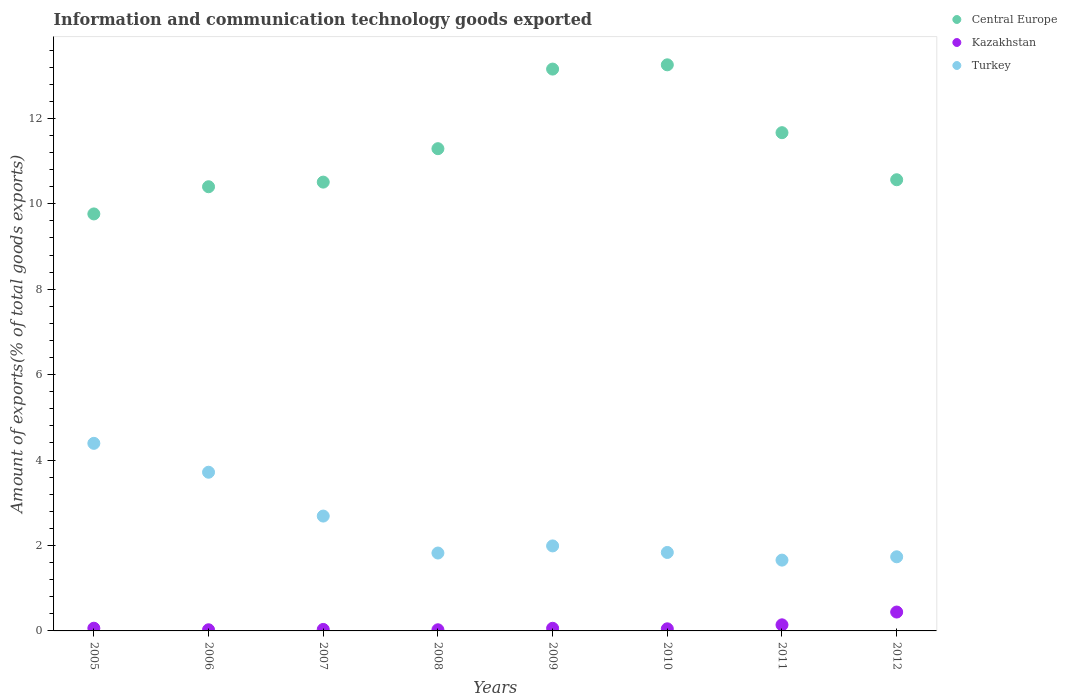What is the amount of goods exported in Kazakhstan in 2010?
Keep it short and to the point. 0.05. Across all years, what is the maximum amount of goods exported in Turkey?
Your response must be concise. 4.39. Across all years, what is the minimum amount of goods exported in Kazakhstan?
Provide a succinct answer. 0.03. In which year was the amount of goods exported in Central Europe maximum?
Provide a succinct answer. 2010. In which year was the amount of goods exported in Central Europe minimum?
Ensure brevity in your answer.  2005. What is the total amount of goods exported in Central Europe in the graph?
Your answer should be very brief. 90.6. What is the difference between the amount of goods exported in Central Europe in 2006 and that in 2012?
Your answer should be very brief. -0.16. What is the difference between the amount of goods exported in Central Europe in 2011 and the amount of goods exported in Turkey in 2012?
Your answer should be compact. 9.93. What is the average amount of goods exported in Turkey per year?
Keep it short and to the point. 2.48. In the year 2006, what is the difference between the amount of goods exported in Central Europe and amount of goods exported in Kazakhstan?
Your answer should be compact. 10.37. What is the ratio of the amount of goods exported in Kazakhstan in 2005 to that in 2011?
Ensure brevity in your answer.  0.44. What is the difference between the highest and the second highest amount of goods exported in Kazakhstan?
Give a very brief answer. 0.3. What is the difference between the highest and the lowest amount of goods exported in Central Europe?
Offer a terse response. 3.49. In how many years, is the amount of goods exported in Turkey greater than the average amount of goods exported in Turkey taken over all years?
Give a very brief answer. 3. Is it the case that in every year, the sum of the amount of goods exported in Turkey and amount of goods exported in Kazakhstan  is greater than the amount of goods exported in Central Europe?
Your answer should be very brief. No. Does the amount of goods exported in Kazakhstan monotonically increase over the years?
Give a very brief answer. No. Is the amount of goods exported in Turkey strictly less than the amount of goods exported in Kazakhstan over the years?
Give a very brief answer. No. How many dotlines are there?
Provide a succinct answer. 3. How many years are there in the graph?
Offer a very short reply. 8. Are the values on the major ticks of Y-axis written in scientific E-notation?
Your answer should be very brief. No. Where does the legend appear in the graph?
Provide a succinct answer. Top right. What is the title of the graph?
Your answer should be very brief. Information and communication technology goods exported. What is the label or title of the Y-axis?
Offer a terse response. Amount of exports(% of total goods exports). What is the Amount of exports(% of total goods exports) of Central Europe in 2005?
Provide a succinct answer. 9.76. What is the Amount of exports(% of total goods exports) in Kazakhstan in 2005?
Offer a terse response. 0.06. What is the Amount of exports(% of total goods exports) of Turkey in 2005?
Your answer should be compact. 4.39. What is the Amount of exports(% of total goods exports) in Central Europe in 2006?
Your answer should be compact. 10.4. What is the Amount of exports(% of total goods exports) in Kazakhstan in 2006?
Provide a succinct answer. 0.03. What is the Amount of exports(% of total goods exports) of Turkey in 2006?
Provide a succinct answer. 3.72. What is the Amount of exports(% of total goods exports) in Central Europe in 2007?
Your response must be concise. 10.51. What is the Amount of exports(% of total goods exports) of Kazakhstan in 2007?
Make the answer very short. 0.03. What is the Amount of exports(% of total goods exports) of Turkey in 2007?
Offer a very short reply. 2.69. What is the Amount of exports(% of total goods exports) of Central Europe in 2008?
Give a very brief answer. 11.29. What is the Amount of exports(% of total goods exports) in Kazakhstan in 2008?
Offer a very short reply. 0.03. What is the Amount of exports(% of total goods exports) in Turkey in 2008?
Your answer should be compact. 1.82. What is the Amount of exports(% of total goods exports) in Central Europe in 2009?
Your answer should be compact. 13.15. What is the Amount of exports(% of total goods exports) of Kazakhstan in 2009?
Offer a terse response. 0.06. What is the Amount of exports(% of total goods exports) of Turkey in 2009?
Offer a very short reply. 1.99. What is the Amount of exports(% of total goods exports) of Central Europe in 2010?
Offer a very short reply. 13.25. What is the Amount of exports(% of total goods exports) of Kazakhstan in 2010?
Give a very brief answer. 0.05. What is the Amount of exports(% of total goods exports) of Turkey in 2010?
Ensure brevity in your answer.  1.84. What is the Amount of exports(% of total goods exports) in Central Europe in 2011?
Your answer should be compact. 11.67. What is the Amount of exports(% of total goods exports) of Kazakhstan in 2011?
Ensure brevity in your answer.  0.14. What is the Amount of exports(% of total goods exports) in Turkey in 2011?
Provide a short and direct response. 1.66. What is the Amount of exports(% of total goods exports) of Central Europe in 2012?
Give a very brief answer. 10.56. What is the Amount of exports(% of total goods exports) in Kazakhstan in 2012?
Give a very brief answer. 0.44. What is the Amount of exports(% of total goods exports) in Turkey in 2012?
Give a very brief answer. 1.74. Across all years, what is the maximum Amount of exports(% of total goods exports) in Central Europe?
Keep it short and to the point. 13.25. Across all years, what is the maximum Amount of exports(% of total goods exports) of Kazakhstan?
Your answer should be very brief. 0.44. Across all years, what is the maximum Amount of exports(% of total goods exports) in Turkey?
Give a very brief answer. 4.39. Across all years, what is the minimum Amount of exports(% of total goods exports) of Central Europe?
Offer a terse response. 9.76. Across all years, what is the minimum Amount of exports(% of total goods exports) of Kazakhstan?
Provide a short and direct response. 0.03. Across all years, what is the minimum Amount of exports(% of total goods exports) in Turkey?
Keep it short and to the point. 1.66. What is the total Amount of exports(% of total goods exports) in Central Europe in the graph?
Keep it short and to the point. 90.6. What is the total Amount of exports(% of total goods exports) in Kazakhstan in the graph?
Offer a very short reply. 0.85. What is the total Amount of exports(% of total goods exports) in Turkey in the graph?
Offer a very short reply. 19.84. What is the difference between the Amount of exports(% of total goods exports) of Central Europe in 2005 and that in 2006?
Provide a short and direct response. -0.64. What is the difference between the Amount of exports(% of total goods exports) of Kazakhstan in 2005 and that in 2006?
Give a very brief answer. 0.04. What is the difference between the Amount of exports(% of total goods exports) of Turkey in 2005 and that in 2006?
Your response must be concise. 0.68. What is the difference between the Amount of exports(% of total goods exports) in Central Europe in 2005 and that in 2007?
Your answer should be compact. -0.74. What is the difference between the Amount of exports(% of total goods exports) of Kazakhstan in 2005 and that in 2007?
Give a very brief answer. 0.03. What is the difference between the Amount of exports(% of total goods exports) of Turkey in 2005 and that in 2007?
Offer a terse response. 1.7. What is the difference between the Amount of exports(% of total goods exports) of Central Europe in 2005 and that in 2008?
Your response must be concise. -1.53. What is the difference between the Amount of exports(% of total goods exports) in Kazakhstan in 2005 and that in 2008?
Make the answer very short. 0.04. What is the difference between the Amount of exports(% of total goods exports) in Turkey in 2005 and that in 2008?
Provide a succinct answer. 2.57. What is the difference between the Amount of exports(% of total goods exports) in Central Europe in 2005 and that in 2009?
Give a very brief answer. -3.39. What is the difference between the Amount of exports(% of total goods exports) of Kazakhstan in 2005 and that in 2009?
Provide a short and direct response. 0. What is the difference between the Amount of exports(% of total goods exports) in Turkey in 2005 and that in 2009?
Offer a very short reply. 2.4. What is the difference between the Amount of exports(% of total goods exports) in Central Europe in 2005 and that in 2010?
Your answer should be very brief. -3.49. What is the difference between the Amount of exports(% of total goods exports) in Kazakhstan in 2005 and that in 2010?
Keep it short and to the point. 0.01. What is the difference between the Amount of exports(% of total goods exports) of Turkey in 2005 and that in 2010?
Your answer should be compact. 2.55. What is the difference between the Amount of exports(% of total goods exports) of Central Europe in 2005 and that in 2011?
Provide a succinct answer. -1.9. What is the difference between the Amount of exports(% of total goods exports) in Kazakhstan in 2005 and that in 2011?
Your response must be concise. -0.08. What is the difference between the Amount of exports(% of total goods exports) in Turkey in 2005 and that in 2011?
Give a very brief answer. 2.73. What is the difference between the Amount of exports(% of total goods exports) of Central Europe in 2005 and that in 2012?
Your answer should be very brief. -0.8. What is the difference between the Amount of exports(% of total goods exports) of Kazakhstan in 2005 and that in 2012?
Your response must be concise. -0.38. What is the difference between the Amount of exports(% of total goods exports) in Turkey in 2005 and that in 2012?
Your answer should be very brief. 2.66. What is the difference between the Amount of exports(% of total goods exports) of Central Europe in 2006 and that in 2007?
Give a very brief answer. -0.11. What is the difference between the Amount of exports(% of total goods exports) of Kazakhstan in 2006 and that in 2007?
Your answer should be very brief. -0.01. What is the difference between the Amount of exports(% of total goods exports) of Turkey in 2006 and that in 2007?
Your answer should be compact. 1.03. What is the difference between the Amount of exports(% of total goods exports) of Central Europe in 2006 and that in 2008?
Keep it short and to the point. -0.89. What is the difference between the Amount of exports(% of total goods exports) in Kazakhstan in 2006 and that in 2008?
Your answer should be very brief. 0. What is the difference between the Amount of exports(% of total goods exports) in Turkey in 2006 and that in 2008?
Give a very brief answer. 1.89. What is the difference between the Amount of exports(% of total goods exports) of Central Europe in 2006 and that in 2009?
Offer a terse response. -2.75. What is the difference between the Amount of exports(% of total goods exports) of Kazakhstan in 2006 and that in 2009?
Ensure brevity in your answer.  -0.03. What is the difference between the Amount of exports(% of total goods exports) in Turkey in 2006 and that in 2009?
Offer a terse response. 1.73. What is the difference between the Amount of exports(% of total goods exports) of Central Europe in 2006 and that in 2010?
Your answer should be very brief. -2.85. What is the difference between the Amount of exports(% of total goods exports) in Kazakhstan in 2006 and that in 2010?
Your answer should be compact. -0.02. What is the difference between the Amount of exports(% of total goods exports) of Turkey in 2006 and that in 2010?
Offer a terse response. 1.88. What is the difference between the Amount of exports(% of total goods exports) in Central Europe in 2006 and that in 2011?
Your answer should be very brief. -1.27. What is the difference between the Amount of exports(% of total goods exports) of Kazakhstan in 2006 and that in 2011?
Give a very brief answer. -0.12. What is the difference between the Amount of exports(% of total goods exports) of Turkey in 2006 and that in 2011?
Your answer should be very brief. 2.06. What is the difference between the Amount of exports(% of total goods exports) of Central Europe in 2006 and that in 2012?
Give a very brief answer. -0.16. What is the difference between the Amount of exports(% of total goods exports) in Kazakhstan in 2006 and that in 2012?
Keep it short and to the point. -0.41. What is the difference between the Amount of exports(% of total goods exports) in Turkey in 2006 and that in 2012?
Your answer should be compact. 1.98. What is the difference between the Amount of exports(% of total goods exports) of Central Europe in 2007 and that in 2008?
Offer a terse response. -0.78. What is the difference between the Amount of exports(% of total goods exports) in Kazakhstan in 2007 and that in 2008?
Provide a short and direct response. 0.01. What is the difference between the Amount of exports(% of total goods exports) of Turkey in 2007 and that in 2008?
Offer a very short reply. 0.87. What is the difference between the Amount of exports(% of total goods exports) of Central Europe in 2007 and that in 2009?
Your answer should be compact. -2.65. What is the difference between the Amount of exports(% of total goods exports) of Kazakhstan in 2007 and that in 2009?
Provide a short and direct response. -0.03. What is the difference between the Amount of exports(% of total goods exports) of Turkey in 2007 and that in 2009?
Make the answer very short. 0.7. What is the difference between the Amount of exports(% of total goods exports) in Central Europe in 2007 and that in 2010?
Provide a succinct answer. -2.75. What is the difference between the Amount of exports(% of total goods exports) of Kazakhstan in 2007 and that in 2010?
Offer a very short reply. -0.01. What is the difference between the Amount of exports(% of total goods exports) of Turkey in 2007 and that in 2010?
Provide a short and direct response. 0.85. What is the difference between the Amount of exports(% of total goods exports) in Central Europe in 2007 and that in 2011?
Provide a succinct answer. -1.16. What is the difference between the Amount of exports(% of total goods exports) in Kazakhstan in 2007 and that in 2011?
Make the answer very short. -0.11. What is the difference between the Amount of exports(% of total goods exports) in Turkey in 2007 and that in 2011?
Provide a short and direct response. 1.03. What is the difference between the Amount of exports(% of total goods exports) in Central Europe in 2007 and that in 2012?
Keep it short and to the point. -0.06. What is the difference between the Amount of exports(% of total goods exports) in Kazakhstan in 2007 and that in 2012?
Your response must be concise. -0.41. What is the difference between the Amount of exports(% of total goods exports) in Turkey in 2007 and that in 2012?
Ensure brevity in your answer.  0.95. What is the difference between the Amount of exports(% of total goods exports) of Central Europe in 2008 and that in 2009?
Provide a succinct answer. -1.86. What is the difference between the Amount of exports(% of total goods exports) in Kazakhstan in 2008 and that in 2009?
Provide a succinct answer. -0.03. What is the difference between the Amount of exports(% of total goods exports) in Turkey in 2008 and that in 2009?
Make the answer very short. -0.17. What is the difference between the Amount of exports(% of total goods exports) in Central Europe in 2008 and that in 2010?
Provide a succinct answer. -1.96. What is the difference between the Amount of exports(% of total goods exports) in Kazakhstan in 2008 and that in 2010?
Your answer should be compact. -0.02. What is the difference between the Amount of exports(% of total goods exports) in Turkey in 2008 and that in 2010?
Provide a short and direct response. -0.01. What is the difference between the Amount of exports(% of total goods exports) in Central Europe in 2008 and that in 2011?
Your answer should be compact. -0.37. What is the difference between the Amount of exports(% of total goods exports) of Kazakhstan in 2008 and that in 2011?
Your answer should be compact. -0.12. What is the difference between the Amount of exports(% of total goods exports) of Turkey in 2008 and that in 2011?
Your answer should be very brief. 0.17. What is the difference between the Amount of exports(% of total goods exports) of Central Europe in 2008 and that in 2012?
Ensure brevity in your answer.  0.73. What is the difference between the Amount of exports(% of total goods exports) of Kazakhstan in 2008 and that in 2012?
Your response must be concise. -0.41. What is the difference between the Amount of exports(% of total goods exports) in Turkey in 2008 and that in 2012?
Ensure brevity in your answer.  0.09. What is the difference between the Amount of exports(% of total goods exports) of Central Europe in 2009 and that in 2010?
Offer a terse response. -0.1. What is the difference between the Amount of exports(% of total goods exports) in Kazakhstan in 2009 and that in 2010?
Your response must be concise. 0.01. What is the difference between the Amount of exports(% of total goods exports) in Turkey in 2009 and that in 2010?
Provide a succinct answer. 0.15. What is the difference between the Amount of exports(% of total goods exports) of Central Europe in 2009 and that in 2011?
Give a very brief answer. 1.49. What is the difference between the Amount of exports(% of total goods exports) in Kazakhstan in 2009 and that in 2011?
Offer a very short reply. -0.08. What is the difference between the Amount of exports(% of total goods exports) in Turkey in 2009 and that in 2011?
Give a very brief answer. 0.33. What is the difference between the Amount of exports(% of total goods exports) of Central Europe in 2009 and that in 2012?
Your response must be concise. 2.59. What is the difference between the Amount of exports(% of total goods exports) of Kazakhstan in 2009 and that in 2012?
Your response must be concise. -0.38. What is the difference between the Amount of exports(% of total goods exports) in Turkey in 2009 and that in 2012?
Your response must be concise. 0.25. What is the difference between the Amount of exports(% of total goods exports) in Central Europe in 2010 and that in 2011?
Offer a terse response. 1.59. What is the difference between the Amount of exports(% of total goods exports) of Kazakhstan in 2010 and that in 2011?
Provide a succinct answer. -0.09. What is the difference between the Amount of exports(% of total goods exports) in Turkey in 2010 and that in 2011?
Your answer should be very brief. 0.18. What is the difference between the Amount of exports(% of total goods exports) of Central Europe in 2010 and that in 2012?
Ensure brevity in your answer.  2.69. What is the difference between the Amount of exports(% of total goods exports) in Kazakhstan in 2010 and that in 2012?
Ensure brevity in your answer.  -0.39. What is the difference between the Amount of exports(% of total goods exports) in Turkey in 2010 and that in 2012?
Keep it short and to the point. 0.1. What is the difference between the Amount of exports(% of total goods exports) in Central Europe in 2011 and that in 2012?
Keep it short and to the point. 1.1. What is the difference between the Amount of exports(% of total goods exports) of Kazakhstan in 2011 and that in 2012?
Give a very brief answer. -0.3. What is the difference between the Amount of exports(% of total goods exports) of Turkey in 2011 and that in 2012?
Keep it short and to the point. -0.08. What is the difference between the Amount of exports(% of total goods exports) of Central Europe in 2005 and the Amount of exports(% of total goods exports) of Kazakhstan in 2006?
Your response must be concise. 9.74. What is the difference between the Amount of exports(% of total goods exports) of Central Europe in 2005 and the Amount of exports(% of total goods exports) of Turkey in 2006?
Provide a short and direct response. 6.05. What is the difference between the Amount of exports(% of total goods exports) in Kazakhstan in 2005 and the Amount of exports(% of total goods exports) in Turkey in 2006?
Provide a short and direct response. -3.65. What is the difference between the Amount of exports(% of total goods exports) in Central Europe in 2005 and the Amount of exports(% of total goods exports) in Kazakhstan in 2007?
Offer a very short reply. 9.73. What is the difference between the Amount of exports(% of total goods exports) in Central Europe in 2005 and the Amount of exports(% of total goods exports) in Turkey in 2007?
Provide a succinct answer. 7.07. What is the difference between the Amount of exports(% of total goods exports) in Kazakhstan in 2005 and the Amount of exports(% of total goods exports) in Turkey in 2007?
Give a very brief answer. -2.63. What is the difference between the Amount of exports(% of total goods exports) of Central Europe in 2005 and the Amount of exports(% of total goods exports) of Kazakhstan in 2008?
Keep it short and to the point. 9.74. What is the difference between the Amount of exports(% of total goods exports) in Central Europe in 2005 and the Amount of exports(% of total goods exports) in Turkey in 2008?
Offer a terse response. 7.94. What is the difference between the Amount of exports(% of total goods exports) in Kazakhstan in 2005 and the Amount of exports(% of total goods exports) in Turkey in 2008?
Ensure brevity in your answer.  -1.76. What is the difference between the Amount of exports(% of total goods exports) of Central Europe in 2005 and the Amount of exports(% of total goods exports) of Kazakhstan in 2009?
Offer a very short reply. 9.7. What is the difference between the Amount of exports(% of total goods exports) of Central Europe in 2005 and the Amount of exports(% of total goods exports) of Turkey in 2009?
Your answer should be very brief. 7.77. What is the difference between the Amount of exports(% of total goods exports) in Kazakhstan in 2005 and the Amount of exports(% of total goods exports) in Turkey in 2009?
Ensure brevity in your answer.  -1.93. What is the difference between the Amount of exports(% of total goods exports) in Central Europe in 2005 and the Amount of exports(% of total goods exports) in Kazakhstan in 2010?
Keep it short and to the point. 9.71. What is the difference between the Amount of exports(% of total goods exports) of Central Europe in 2005 and the Amount of exports(% of total goods exports) of Turkey in 2010?
Your answer should be very brief. 7.93. What is the difference between the Amount of exports(% of total goods exports) of Kazakhstan in 2005 and the Amount of exports(% of total goods exports) of Turkey in 2010?
Provide a short and direct response. -1.77. What is the difference between the Amount of exports(% of total goods exports) in Central Europe in 2005 and the Amount of exports(% of total goods exports) in Kazakhstan in 2011?
Provide a succinct answer. 9.62. What is the difference between the Amount of exports(% of total goods exports) of Central Europe in 2005 and the Amount of exports(% of total goods exports) of Turkey in 2011?
Keep it short and to the point. 8.11. What is the difference between the Amount of exports(% of total goods exports) in Kazakhstan in 2005 and the Amount of exports(% of total goods exports) in Turkey in 2011?
Ensure brevity in your answer.  -1.59. What is the difference between the Amount of exports(% of total goods exports) in Central Europe in 2005 and the Amount of exports(% of total goods exports) in Kazakhstan in 2012?
Keep it short and to the point. 9.32. What is the difference between the Amount of exports(% of total goods exports) of Central Europe in 2005 and the Amount of exports(% of total goods exports) of Turkey in 2012?
Make the answer very short. 8.03. What is the difference between the Amount of exports(% of total goods exports) in Kazakhstan in 2005 and the Amount of exports(% of total goods exports) in Turkey in 2012?
Ensure brevity in your answer.  -1.67. What is the difference between the Amount of exports(% of total goods exports) of Central Europe in 2006 and the Amount of exports(% of total goods exports) of Kazakhstan in 2007?
Offer a terse response. 10.36. What is the difference between the Amount of exports(% of total goods exports) of Central Europe in 2006 and the Amount of exports(% of total goods exports) of Turkey in 2007?
Your response must be concise. 7.71. What is the difference between the Amount of exports(% of total goods exports) in Kazakhstan in 2006 and the Amount of exports(% of total goods exports) in Turkey in 2007?
Give a very brief answer. -2.66. What is the difference between the Amount of exports(% of total goods exports) in Central Europe in 2006 and the Amount of exports(% of total goods exports) in Kazakhstan in 2008?
Ensure brevity in your answer.  10.37. What is the difference between the Amount of exports(% of total goods exports) in Central Europe in 2006 and the Amount of exports(% of total goods exports) in Turkey in 2008?
Provide a short and direct response. 8.58. What is the difference between the Amount of exports(% of total goods exports) of Kazakhstan in 2006 and the Amount of exports(% of total goods exports) of Turkey in 2008?
Offer a very short reply. -1.8. What is the difference between the Amount of exports(% of total goods exports) in Central Europe in 2006 and the Amount of exports(% of total goods exports) in Kazakhstan in 2009?
Your answer should be very brief. 10.34. What is the difference between the Amount of exports(% of total goods exports) in Central Europe in 2006 and the Amount of exports(% of total goods exports) in Turkey in 2009?
Your answer should be very brief. 8.41. What is the difference between the Amount of exports(% of total goods exports) of Kazakhstan in 2006 and the Amount of exports(% of total goods exports) of Turkey in 2009?
Your answer should be compact. -1.96. What is the difference between the Amount of exports(% of total goods exports) of Central Europe in 2006 and the Amount of exports(% of total goods exports) of Kazakhstan in 2010?
Provide a succinct answer. 10.35. What is the difference between the Amount of exports(% of total goods exports) of Central Europe in 2006 and the Amount of exports(% of total goods exports) of Turkey in 2010?
Make the answer very short. 8.56. What is the difference between the Amount of exports(% of total goods exports) in Kazakhstan in 2006 and the Amount of exports(% of total goods exports) in Turkey in 2010?
Your answer should be very brief. -1.81. What is the difference between the Amount of exports(% of total goods exports) of Central Europe in 2006 and the Amount of exports(% of total goods exports) of Kazakhstan in 2011?
Provide a succinct answer. 10.26. What is the difference between the Amount of exports(% of total goods exports) in Central Europe in 2006 and the Amount of exports(% of total goods exports) in Turkey in 2011?
Your answer should be very brief. 8.74. What is the difference between the Amount of exports(% of total goods exports) in Kazakhstan in 2006 and the Amount of exports(% of total goods exports) in Turkey in 2011?
Offer a very short reply. -1.63. What is the difference between the Amount of exports(% of total goods exports) in Central Europe in 2006 and the Amount of exports(% of total goods exports) in Kazakhstan in 2012?
Offer a very short reply. 9.96. What is the difference between the Amount of exports(% of total goods exports) in Central Europe in 2006 and the Amount of exports(% of total goods exports) in Turkey in 2012?
Offer a very short reply. 8.66. What is the difference between the Amount of exports(% of total goods exports) in Kazakhstan in 2006 and the Amount of exports(% of total goods exports) in Turkey in 2012?
Ensure brevity in your answer.  -1.71. What is the difference between the Amount of exports(% of total goods exports) of Central Europe in 2007 and the Amount of exports(% of total goods exports) of Kazakhstan in 2008?
Give a very brief answer. 10.48. What is the difference between the Amount of exports(% of total goods exports) of Central Europe in 2007 and the Amount of exports(% of total goods exports) of Turkey in 2008?
Offer a very short reply. 8.68. What is the difference between the Amount of exports(% of total goods exports) in Kazakhstan in 2007 and the Amount of exports(% of total goods exports) in Turkey in 2008?
Provide a succinct answer. -1.79. What is the difference between the Amount of exports(% of total goods exports) of Central Europe in 2007 and the Amount of exports(% of total goods exports) of Kazakhstan in 2009?
Offer a very short reply. 10.45. What is the difference between the Amount of exports(% of total goods exports) of Central Europe in 2007 and the Amount of exports(% of total goods exports) of Turkey in 2009?
Provide a succinct answer. 8.52. What is the difference between the Amount of exports(% of total goods exports) in Kazakhstan in 2007 and the Amount of exports(% of total goods exports) in Turkey in 2009?
Provide a succinct answer. -1.96. What is the difference between the Amount of exports(% of total goods exports) in Central Europe in 2007 and the Amount of exports(% of total goods exports) in Kazakhstan in 2010?
Your answer should be very brief. 10.46. What is the difference between the Amount of exports(% of total goods exports) of Central Europe in 2007 and the Amount of exports(% of total goods exports) of Turkey in 2010?
Give a very brief answer. 8.67. What is the difference between the Amount of exports(% of total goods exports) in Kazakhstan in 2007 and the Amount of exports(% of total goods exports) in Turkey in 2010?
Your response must be concise. -1.8. What is the difference between the Amount of exports(% of total goods exports) of Central Europe in 2007 and the Amount of exports(% of total goods exports) of Kazakhstan in 2011?
Give a very brief answer. 10.37. What is the difference between the Amount of exports(% of total goods exports) of Central Europe in 2007 and the Amount of exports(% of total goods exports) of Turkey in 2011?
Your answer should be very brief. 8.85. What is the difference between the Amount of exports(% of total goods exports) in Kazakhstan in 2007 and the Amount of exports(% of total goods exports) in Turkey in 2011?
Provide a succinct answer. -1.62. What is the difference between the Amount of exports(% of total goods exports) of Central Europe in 2007 and the Amount of exports(% of total goods exports) of Kazakhstan in 2012?
Give a very brief answer. 10.07. What is the difference between the Amount of exports(% of total goods exports) in Central Europe in 2007 and the Amount of exports(% of total goods exports) in Turkey in 2012?
Keep it short and to the point. 8.77. What is the difference between the Amount of exports(% of total goods exports) of Kazakhstan in 2007 and the Amount of exports(% of total goods exports) of Turkey in 2012?
Provide a succinct answer. -1.7. What is the difference between the Amount of exports(% of total goods exports) of Central Europe in 2008 and the Amount of exports(% of total goods exports) of Kazakhstan in 2009?
Your answer should be compact. 11.23. What is the difference between the Amount of exports(% of total goods exports) of Central Europe in 2008 and the Amount of exports(% of total goods exports) of Turkey in 2009?
Provide a short and direct response. 9.3. What is the difference between the Amount of exports(% of total goods exports) in Kazakhstan in 2008 and the Amount of exports(% of total goods exports) in Turkey in 2009?
Offer a very short reply. -1.96. What is the difference between the Amount of exports(% of total goods exports) in Central Europe in 2008 and the Amount of exports(% of total goods exports) in Kazakhstan in 2010?
Provide a succinct answer. 11.24. What is the difference between the Amount of exports(% of total goods exports) in Central Europe in 2008 and the Amount of exports(% of total goods exports) in Turkey in 2010?
Your answer should be very brief. 9.45. What is the difference between the Amount of exports(% of total goods exports) in Kazakhstan in 2008 and the Amount of exports(% of total goods exports) in Turkey in 2010?
Ensure brevity in your answer.  -1.81. What is the difference between the Amount of exports(% of total goods exports) of Central Europe in 2008 and the Amount of exports(% of total goods exports) of Kazakhstan in 2011?
Provide a short and direct response. 11.15. What is the difference between the Amount of exports(% of total goods exports) of Central Europe in 2008 and the Amount of exports(% of total goods exports) of Turkey in 2011?
Your answer should be very brief. 9.63. What is the difference between the Amount of exports(% of total goods exports) in Kazakhstan in 2008 and the Amount of exports(% of total goods exports) in Turkey in 2011?
Your response must be concise. -1.63. What is the difference between the Amount of exports(% of total goods exports) in Central Europe in 2008 and the Amount of exports(% of total goods exports) in Kazakhstan in 2012?
Ensure brevity in your answer.  10.85. What is the difference between the Amount of exports(% of total goods exports) in Central Europe in 2008 and the Amount of exports(% of total goods exports) in Turkey in 2012?
Provide a short and direct response. 9.56. What is the difference between the Amount of exports(% of total goods exports) of Kazakhstan in 2008 and the Amount of exports(% of total goods exports) of Turkey in 2012?
Offer a terse response. -1.71. What is the difference between the Amount of exports(% of total goods exports) in Central Europe in 2009 and the Amount of exports(% of total goods exports) in Kazakhstan in 2010?
Offer a very short reply. 13.11. What is the difference between the Amount of exports(% of total goods exports) of Central Europe in 2009 and the Amount of exports(% of total goods exports) of Turkey in 2010?
Provide a short and direct response. 11.32. What is the difference between the Amount of exports(% of total goods exports) of Kazakhstan in 2009 and the Amount of exports(% of total goods exports) of Turkey in 2010?
Offer a very short reply. -1.78. What is the difference between the Amount of exports(% of total goods exports) of Central Europe in 2009 and the Amount of exports(% of total goods exports) of Kazakhstan in 2011?
Offer a terse response. 13.01. What is the difference between the Amount of exports(% of total goods exports) in Central Europe in 2009 and the Amount of exports(% of total goods exports) in Turkey in 2011?
Keep it short and to the point. 11.5. What is the difference between the Amount of exports(% of total goods exports) in Kazakhstan in 2009 and the Amount of exports(% of total goods exports) in Turkey in 2011?
Your answer should be compact. -1.6. What is the difference between the Amount of exports(% of total goods exports) of Central Europe in 2009 and the Amount of exports(% of total goods exports) of Kazakhstan in 2012?
Ensure brevity in your answer.  12.71. What is the difference between the Amount of exports(% of total goods exports) in Central Europe in 2009 and the Amount of exports(% of total goods exports) in Turkey in 2012?
Give a very brief answer. 11.42. What is the difference between the Amount of exports(% of total goods exports) of Kazakhstan in 2009 and the Amount of exports(% of total goods exports) of Turkey in 2012?
Give a very brief answer. -1.67. What is the difference between the Amount of exports(% of total goods exports) of Central Europe in 2010 and the Amount of exports(% of total goods exports) of Kazakhstan in 2011?
Your answer should be compact. 13.11. What is the difference between the Amount of exports(% of total goods exports) of Central Europe in 2010 and the Amount of exports(% of total goods exports) of Turkey in 2011?
Make the answer very short. 11.6. What is the difference between the Amount of exports(% of total goods exports) of Kazakhstan in 2010 and the Amount of exports(% of total goods exports) of Turkey in 2011?
Offer a terse response. -1.61. What is the difference between the Amount of exports(% of total goods exports) in Central Europe in 2010 and the Amount of exports(% of total goods exports) in Kazakhstan in 2012?
Your answer should be compact. 12.81. What is the difference between the Amount of exports(% of total goods exports) of Central Europe in 2010 and the Amount of exports(% of total goods exports) of Turkey in 2012?
Your response must be concise. 11.52. What is the difference between the Amount of exports(% of total goods exports) of Kazakhstan in 2010 and the Amount of exports(% of total goods exports) of Turkey in 2012?
Keep it short and to the point. -1.69. What is the difference between the Amount of exports(% of total goods exports) in Central Europe in 2011 and the Amount of exports(% of total goods exports) in Kazakhstan in 2012?
Provide a succinct answer. 11.22. What is the difference between the Amount of exports(% of total goods exports) in Central Europe in 2011 and the Amount of exports(% of total goods exports) in Turkey in 2012?
Make the answer very short. 9.93. What is the difference between the Amount of exports(% of total goods exports) of Kazakhstan in 2011 and the Amount of exports(% of total goods exports) of Turkey in 2012?
Give a very brief answer. -1.59. What is the average Amount of exports(% of total goods exports) in Central Europe per year?
Your answer should be very brief. 11.32. What is the average Amount of exports(% of total goods exports) of Kazakhstan per year?
Ensure brevity in your answer.  0.11. What is the average Amount of exports(% of total goods exports) in Turkey per year?
Your response must be concise. 2.48. In the year 2005, what is the difference between the Amount of exports(% of total goods exports) in Central Europe and Amount of exports(% of total goods exports) in Kazakhstan?
Offer a very short reply. 9.7. In the year 2005, what is the difference between the Amount of exports(% of total goods exports) of Central Europe and Amount of exports(% of total goods exports) of Turkey?
Provide a succinct answer. 5.37. In the year 2005, what is the difference between the Amount of exports(% of total goods exports) in Kazakhstan and Amount of exports(% of total goods exports) in Turkey?
Provide a short and direct response. -4.33. In the year 2006, what is the difference between the Amount of exports(% of total goods exports) of Central Europe and Amount of exports(% of total goods exports) of Kazakhstan?
Ensure brevity in your answer.  10.37. In the year 2006, what is the difference between the Amount of exports(% of total goods exports) of Central Europe and Amount of exports(% of total goods exports) of Turkey?
Ensure brevity in your answer.  6.68. In the year 2006, what is the difference between the Amount of exports(% of total goods exports) of Kazakhstan and Amount of exports(% of total goods exports) of Turkey?
Your response must be concise. -3.69. In the year 2007, what is the difference between the Amount of exports(% of total goods exports) in Central Europe and Amount of exports(% of total goods exports) in Kazakhstan?
Offer a terse response. 10.47. In the year 2007, what is the difference between the Amount of exports(% of total goods exports) in Central Europe and Amount of exports(% of total goods exports) in Turkey?
Make the answer very short. 7.82. In the year 2007, what is the difference between the Amount of exports(% of total goods exports) of Kazakhstan and Amount of exports(% of total goods exports) of Turkey?
Your answer should be compact. -2.65. In the year 2008, what is the difference between the Amount of exports(% of total goods exports) of Central Europe and Amount of exports(% of total goods exports) of Kazakhstan?
Ensure brevity in your answer.  11.26. In the year 2008, what is the difference between the Amount of exports(% of total goods exports) in Central Europe and Amount of exports(% of total goods exports) in Turkey?
Ensure brevity in your answer.  9.47. In the year 2008, what is the difference between the Amount of exports(% of total goods exports) in Kazakhstan and Amount of exports(% of total goods exports) in Turkey?
Keep it short and to the point. -1.8. In the year 2009, what is the difference between the Amount of exports(% of total goods exports) of Central Europe and Amount of exports(% of total goods exports) of Kazakhstan?
Your response must be concise. 13.09. In the year 2009, what is the difference between the Amount of exports(% of total goods exports) of Central Europe and Amount of exports(% of total goods exports) of Turkey?
Make the answer very short. 11.16. In the year 2009, what is the difference between the Amount of exports(% of total goods exports) in Kazakhstan and Amount of exports(% of total goods exports) in Turkey?
Your answer should be compact. -1.93. In the year 2010, what is the difference between the Amount of exports(% of total goods exports) of Central Europe and Amount of exports(% of total goods exports) of Kazakhstan?
Provide a succinct answer. 13.2. In the year 2010, what is the difference between the Amount of exports(% of total goods exports) in Central Europe and Amount of exports(% of total goods exports) in Turkey?
Provide a short and direct response. 11.42. In the year 2010, what is the difference between the Amount of exports(% of total goods exports) in Kazakhstan and Amount of exports(% of total goods exports) in Turkey?
Offer a terse response. -1.79. In the year 2011, what is the difference between the Amount of exports(% of total goods exports) in Central Europe and Amount of exports(% of total goods exports) in Kazakhstan?
Offer a very short reply. 11.52. In the year 2011, what is the difference between the Amount of exports(% of total goods exports) of Central Europe and Amount of exports(% of total goods exports) of Turkey?
Make the answer very short. 10.01. In the year 2011, what is the difference between the Amount of exports(% of total goods exports) of Kazakhstan and Amount of exports(% of total goods exports) of Turkey?
Offer a very short reply. -1.52. In the year 2012, what is the difference between the Amount of exports(% of total goods exports) in Central Europe and Amount of exports(% of total goods exports) in Kazakhstan?
Offer a terse response. 10.12. In the year 2012, what is the difference between the Amount of exports(% of total goods exports) in Central Europe and Amount of exports(% of total goods exports) in Turkey?
Make the answer very short. 8.83. In the year 2012, what is the difference between the Amount of exports(% of total goods exports) of Kazakhstan and Amount of exports(% of total goods exports) of Turkey?
Offer a very short reply. -1.29. What is the ratio of the Amount of exports(% of total goods exports) in Central Europe in 2005 to that in 2006?
Ensure brevity in your answer.  0.94. What is the ratio of the Amount of exports(% of total goods exports) of Kazakhstan in 2005 to that in 2006?
Your response must be concise. 2.34. What is the ratio of the Amount of exports(% of total goods exports) of Turkey in 2005 to that in 2006?
Make the answer very short. 1.18. What is the ratio of the Amount of exports(% of total goods exports) in Central Europe in 2005 to that in 2007?
Offer a terse response. 0.93. What is the ratio of the Amount of exports(% of total goods exports) of Kazakhstan in 2005 to that in 2007?
Your response must be concise. 1.81. What is the ratio of the Amount of exports(% of total goods exports) of Turkey in 2005 to that in 2007?
Provide a short and direct response. 1.63. What is the ratio of the Amount of exports(% of total goods exports) in Central Europe in 2005 to that in 2008?
Keep it short and to the point. 0.86. What is the ratio of the Amount of exports(% of total goods exports) in Kazakhstan in 2005 to that in 2008?
Provide a succinct answer. 2.35. What is the ratio of the Amount of exports(% of total goods exports) in Turkey in 2005 to that in 2008?
Your response must be concise. 2.41. What is the ratio of the Amount of exports(% of total goods exports) of Central Europe in 2005 to that in 2009?
Make the answer very short. 0.74. What is the ratio of the Amount of exports(% of total goods exports) in Kazakhstan in 2005 to that in 2009?
Your response must be concise. 1.03. What is the ratio of the Amount of exports(% of total goods exports) of Turkey in 2005 to that in 2009?
Your answer should be compact. 2.21. What is the ratio of the Amount of exports(% of total goods exports) of Central Europe in 2005 to that in 2010?
Your response must be concise. 0.74. What is the ratio of the Amount of exports(% of total goods exports) of Kazakhstan in 2005 to that in 2010?
Provide a succinct answer. 1.29. What is the ratio of the Amount of exports(% of total goods exports) of Turkey in 2005 to that in 2010?
Your response must be concise. 2.39. What is the ratio of the Amount of exports(% of total goods exports) of Central Europe in 2005 to that in 2011?
Keep it short and to the point. 0.84. What is the ratio of the Amount of exports(% of total goods exports) of Kazakhstan in 2005 to that in 2011?
Make the answer very short. 0.44. What is the ratio of the Amount of exports(% of total goods exports) of Turkey in 2005 to that in 2011?
Your answer should be very brief. 2.65. What is the ratio of the Amount of exports(% of total goods exports) of Central Europe in 2005 to that in 2012?
Provide a succinct answer. 0.92. What is the ratio of the Amount of exports(% of total goods exports) in Kazakhstan in 2005 to that in 2012?
Offer a very short reply. 0.14. What is the ratio of the Amount of exports(% of total goods exports) of Turkey in 2005 to that in 2012?
Your answer should be very brief. 2.53. What is the ratio of the Amount of exports(% of total goods exports) of Kazakhstan in 2006 to that in 2007?
Your response must be concise. 0.77. What is the ratio of the Amount of exports(% of total goods exports) in Turkey in 2006 to that in 2007?
Keep it short and to the point. 1.38. What is the ratio of the Amount of exports(% of total goods exports) of Central Europe in 2006 to that in 2008?
Offer a terse response. 0.92. What is the ratio of the Amount of exports(% of total goods exports) in Turkey in 2006 to that in 2008?
Provide a succinct answer. 2.04. What is the ratio of the Amount of exports(% of total goods exports) of Central Europe in 2006 to that in 2009?
Keep it short and to the point. 0.79. What is the ratio of the Amount of exports(% of total goods exports) of Kazakhstan in 2006 to that in 2009?
Provide a short and direct response. 0.44. What is the ratio of the Amount of exports(% of total goods exports) in Turkey in 2006 to that in 2009?
Provide a succinct answer. 1.87. What is the ratio of the Amount of exports(% of total goods exports) of Central Europe in 2006 to that in 2010?
Provide a short and direct response. 0.78. What is the ratio of the Amount of exports(% of total goods exports) of Kazakhstan in 2006 to that in 2010?
Your response must be concise. 0.55. What is the ratio of the Amount of exports(% of total goods exports) in Turkey in 2006 to that in 2010?
Keep it short and to the point. 2.02. What is the ratio of the Amount of exports(% of total goods exports) of Central Europe in 2006 to that in 2011?
Ensure brevity in your answer.  0.89. What is the ratio of the Amount of exports(% of total goods exports) in Kazakhstan in 2006 to that in 2011?
Give a very brief answer. 0.19. What is the ratio of the Amount of exports(% of total goods exports) in Turkey in 2006 to that in 2011?
Keep it short and to the point. 2.24. What is the ratio of the Amount of exports(% of total goods exports) of Central Europe in 2006 to that in 2012?
Your answer should be very brief. 0.98. What is the ratio of the Amount of exports(% of total goods exports) of Kazakhstan in 2006 to that in 2012?
Your answer should be very brief. 0.06. What is the ratio of the Amount of exports(% of total goods exports) in Turkey in 2006 to that in 2012?
Keep it short and to the point. 2.14. What is the ratio of the Amount of exports(% of total goods exports) of Central Europe in 2007 to that in 2008?
Your response must be concise. 0.93. What is the ratio of the Amount of exports(% of total goods exports) of Kazakhstan in 2007 to that in 2008?
Offer a terse response. 1.3. What is the ratio of the Amount of exports(% of total goods exports) in Turkey in 2007 to that in 2008?
Offer a terse response. 1.47. What is the ratio of the Amount of exports(% of total goods exports) of Central Europe in 2007 to that in 2009?
Offer a terse response. 0.8. What is the ratio of the Amount of exports(% of total goods exports) in Kazakhstan in 2007 to that in 2009?
Offer a terse response. 0.57. What is the ratio of the Amount of exports(% of total goods exports) of Turkey in 2007 to that in 2009?
Provide a succinct answer. 1.35. What is the ratio of the Amount of exports(% of total goods exports) of Central Europe in 2007 to that in 2010?
Provide a succinct answer. 0.79. What is the ratio of the Amount of exports(% of total goods exports) of Kazakhstan in 2007 to that in 2010?
Keep it short and to the point. 0.71. What is the ratio of the Amount of exports(% of total goods exports) of Turkey in 2007 to that in 2010?
Ensure brevity in your answer.  1.46. What is the ratio of the Amount of exports(% of total goods exports) in Central Europe in 2007 to that in 2011?
Give a very brief answer. 0.9. What is the ratio of the Amount of exports(% of total goods exports) of Kazakhstan in 2007 to that in 2011?
Ensure brevity in your answer.  0.25. What is the ratio of the Amount of exports(% of total goods exports) of Turkey in 2007 to that in 2011?
Offer a terse response. 1.62. What is the ratio of the Amount of exports(% of total goods exports) of Central Europe in 2007 to that in 2012?
Make the answer very short. 0.99. What is the ratio of the Amount of exports(% of total goods exports) in Kazakhstan in 2007 to that in 2012?
Provide a short and direct response. 0.08. What is the ratio of the Amount of exports(% of total goods exports) of Turkey in 2007 to that in 2012?
Your answer should be very brief. 1.55. What is the ratio of the Amount of exports(% of total goods exports) in Central Europe in 2008 to that in 2009?
Your answer should be very brief. 0.86. What is the ratio of the Amount of exports(% of total goods exports) in Kazakhstan in 2008 to that in 2009?
Provide a succinct answer. 0.44. What is the ratio of the Amount of exports(% of total goods exports) in Turkey in 2008 to that in 2009?
Keep it short and to the point. 0.92. What is the ratio of the Amount of exports(% of total goods exports) of Central Europe in 2008 to that in 2010?
Provide a succinct answer. 0.85. What is the ratio of the Amount of exports(% of total goods exports) in Kazakhstan in 2008 to that in 2010?
Give a very brief answer. 0.55. What is the ratio of the Amount of exports(% of total goods exports) in Central Europe in 2008 to that in 2011?
Provide a succinct answer. 0.97. What is the ratio of the Amount of exports(% of total goods exports) of Kazakhstan in 2008 to that in 2011?
Provide a short and direct response. 0.19. What is the ratio of the Amount of exports(% of total goods exports) of Turkey in 2008 to that in 2011?
Provide a short and direct response. 1.1. What is the ratio of the Amount of exports(% of total goods exports) of Central Europe in 2008 to that in 2012?
Ensure brevity in your answer.  1.07. What is the ratio of the Amount of exports(% of total goods exports) in Kazakhstan in 2008 to that in 2012?
Your answer should be compact. 0.06. What is the ratio of the Amount of exports(% of total goods exports) in Turkey in 2008 to that in 2012?
Offer a very short reply. 1.05. What is the ratio of the Amount of exports(% of total goods exports) of Central Europe in 2009 to that in 2010?
Your answer should be very brief. 0.99. What is the ratio of the Amount of exports(% of total goods exports) in Kazakhstan in 2009 to that in 2010?
Your answer should be compact. 1.25. What is the ratio of the Amount of exports(% of total goods exports) of Turkey in 2009 to that in 2010?
Offer a very short reply. 1.08. What is the ratio of the Amount of exports(% of total goods exports) in Central Europe in 2009 to that in 2011?
Your answer should be very brief. 1.13. What is the ratio of the Amount of exports(% of total goods exports) in Kazakhstan in 2009 to that in 2011?
Your answer should be very brief. 0.43. What is the ratio of the Amount of exports(% of total goods exports) of Turkey in 2009 to that in 2011?
Ensure brevity in your answer.  1.2. What is the ratio of the Amount of exports(% of total goods exports) of Central Europe in 2009 to that in 2012?
Offer a very short reply. 1.25. What is the ratio of the Amount of exports(% of total goods exports) of Kazakhstan in 2009 to that in 2012?
Make the answer very short. 0.14. What is the ratio of the Amount of exports(% of total goods exports) in Turkey in 2009 to that in 2012?
Provide a short and direct response. 1.15. What is the ratio of the Amount of exports(% of total goods exports) of Central Europe in 2010 to that in 2011?
Make the answer very short. 1.14. What is the ratio of the Amount of exports(% of total goods exports) in Kazakhstan in 2010 to that in 2011?
Ensure brevity in your answer.  0.35. What is the ratio of the Amount of exports(% of total goods exports) in Turkey in 2010 to that in 2011?
Your response must be concise. 1.11. What is the ratio of the Amount of exports(% of total goods exports) of Central Europe in 2010 to that in 2012?
Provide a succinct answer. 1.25. What is the ratio of the Amount of exports(% of total goods exports) of Kazakhstan in 2010 to that in 2012?
Give a very brief answer. 0.11. What is the ratio of the Amount of exports(% of total goods exports) of Turkey in 2010 to that in 2012?
Offer a very short reply. 1.06. What is the ratio of the Amount of exports(% of total goods exports) in Central Europe in 2011 to that in 2012?
Provide a short and direct response. 1.1. What is the ratio of the Amount of exports(% of total goods exports) in Kazakhstan in 2011 to that in 2012?
Your answer should be compact. 0.32. What is the ratio of the Amount of exports(% of total goods exports) of Turkey in 2011 to that in 2012?
Ensure brevity in your answer.  0.96. What is the difference between the highest and the second highest Amount of exports(% of total goods exports) in Central Europe?
Your answer should be compact. 0.1. What is the difference between the highest and the second highest Amount of exports(% of total goods exports) of Kazakhstan?
Ensure brevity in your answer.  0.3. What is the difference between the highest and the second highest Amount of exports(% of total goods exports) of Turkey?
Your answer should be compact. 0.68. What is the difference between the highest and the lowest Amount of exports(% of total goods exports) of Central Europe?
Give a very brief answer. 3.49. What is the difference between the highest and the lowest Amount of exports(% of total goods exports) in Kazakhstan?
Your answer should be compact. 0.41. What is the difference between the highest and the lowest Amount of exports(% of total goods exports) of Turkey?
Your answer should be compact. 2.73. 